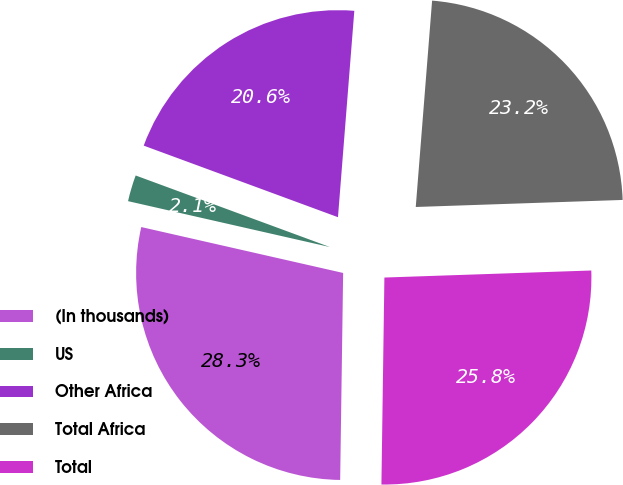Convert chart to OTSL. <chart><loc_0><loc_0><loc_500><loc_500><pie_chart><fcel>(In thousands)<fcel>US<fcel>Other Africa<fcel>Total Africa<fcel>Total<nl><fcel>28.33%<fcel>2.06%<fcel>20.64%<fcel>23.2%<fcel>25.77%<nl></chart> 